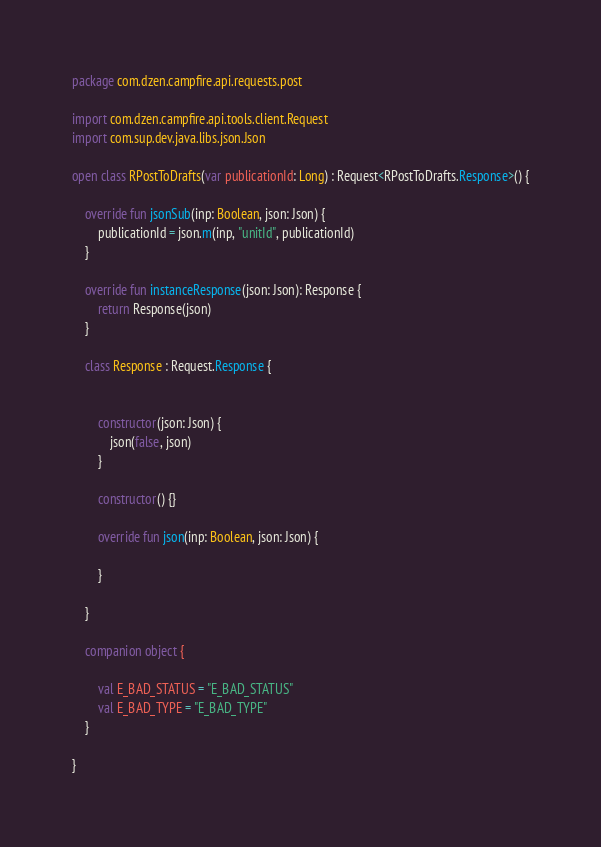<code> <loc_0><loc_0><loc_500><loc_500><_Kotlin_>package com.dzen.campfire.api.requests.post

import com.dzen.campfire.api.tools.client.Request
import com.sup.dev.java.libs.json.Json

open class RPostToDrafts(var publicationId: Long) : Request<RPostToDrafts.Response>() {

    override fun jsonSub(inp: Boolean, json: Json) {
        publicationId = json.m(inp, "unitId", publicationId)
    }

    override fun instanceResponse(json: Json): Response {
        return Response(json)
    }

    class Response : Request.Response {


        constructor(json: Json) {
            json(false, json)
        }

        constructor() {}

        override fun json(inp: Boolean, json: Json) {

        }

    }

    companion object {

        val E_BAD_STATUS = "E_BAD_STATUS"
        val E_BAD_TYPE = "E_BAD_TYPE"
    }

}</code> 